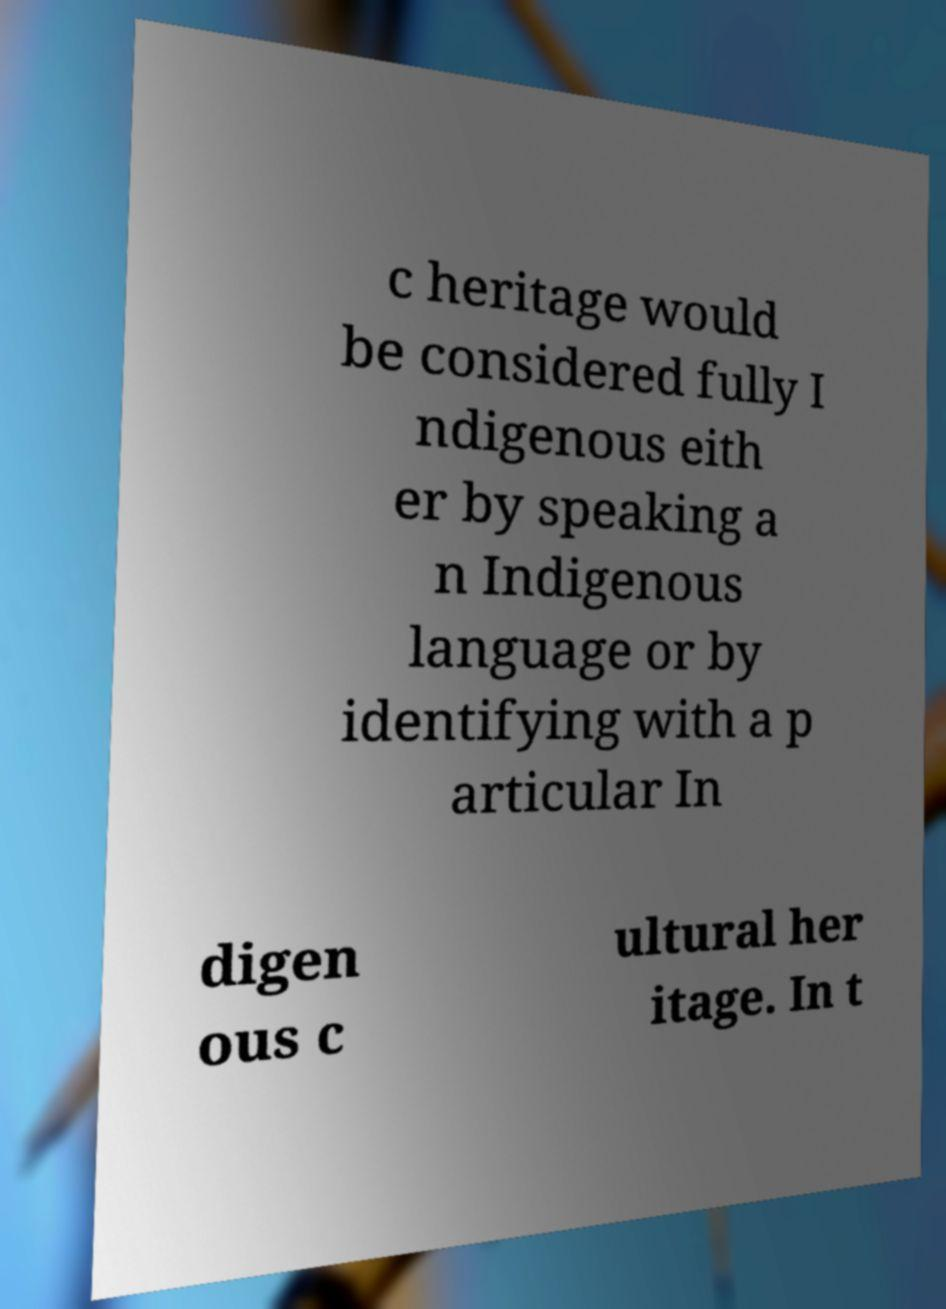Please read and relay the text visible in this image. What does it say? c heritage would be considered fully I ndigenous eith er by speaking a n Indigenous language or by identifying with a p articular In digen ous c ultural her itage. In t 